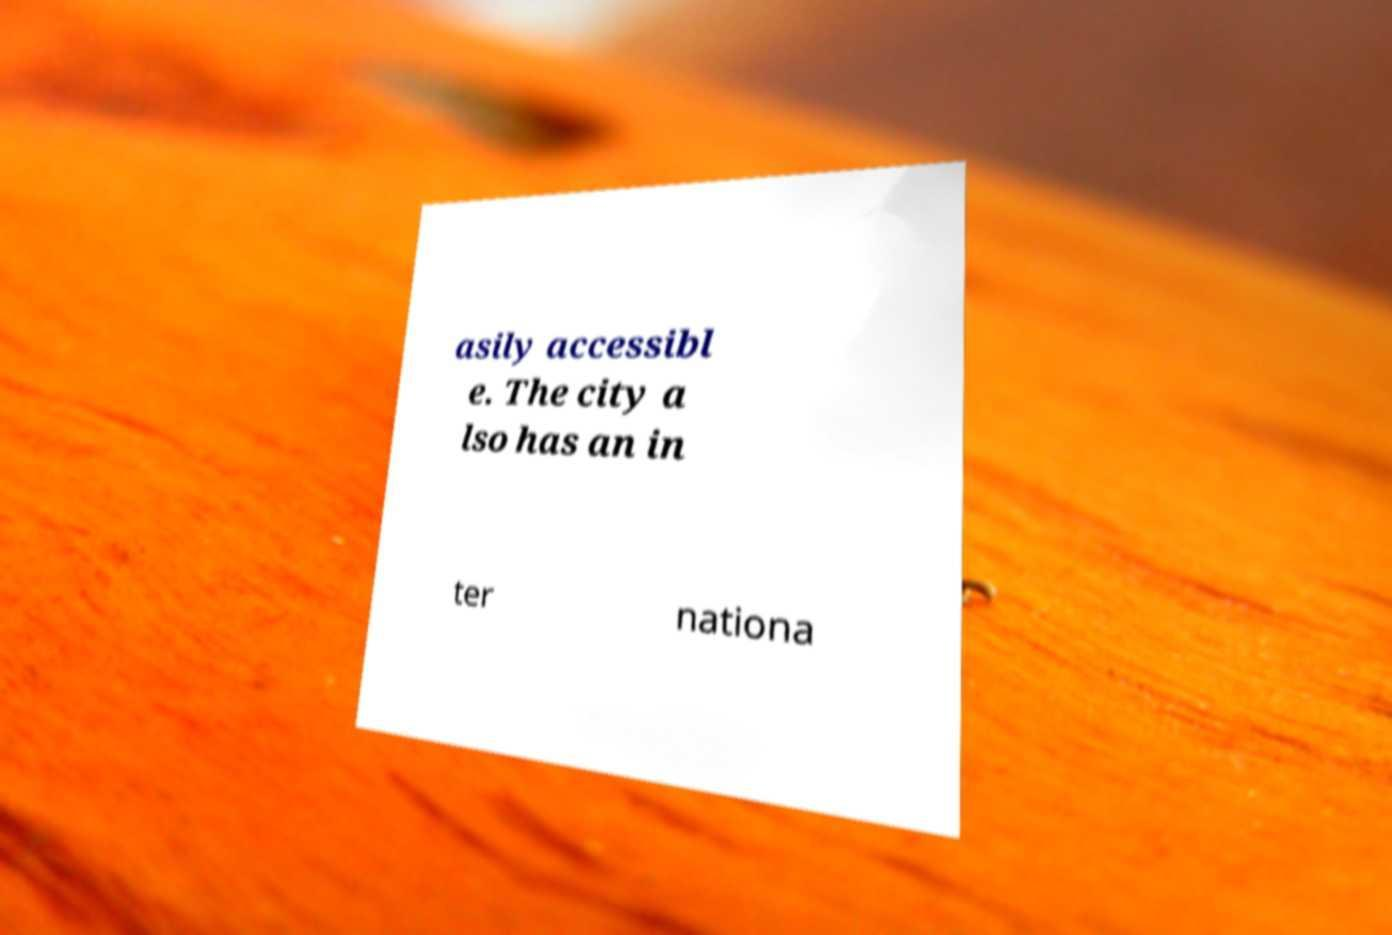Could you assist in decoding the text presented in this image and type it out clearly? asily accessibl e. The city a lso has an in ter nationa 